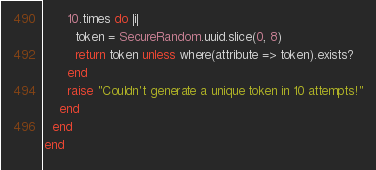<code> <loc_0><loc_0><loc_500><loc_500><_Ruby_>      10.times do |i|
        token = SecureRandom.uuid.slice(0, 8)
        return token unless where(attribute => token).exists?
      end
      raise "Couldn't generate a unique token in 10 attempts!"
    end
  end
end
</code> 